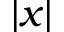Convert formula to latex. <formula><loc_0><loc_0><loc_500><loc_500>| x |</formula> 